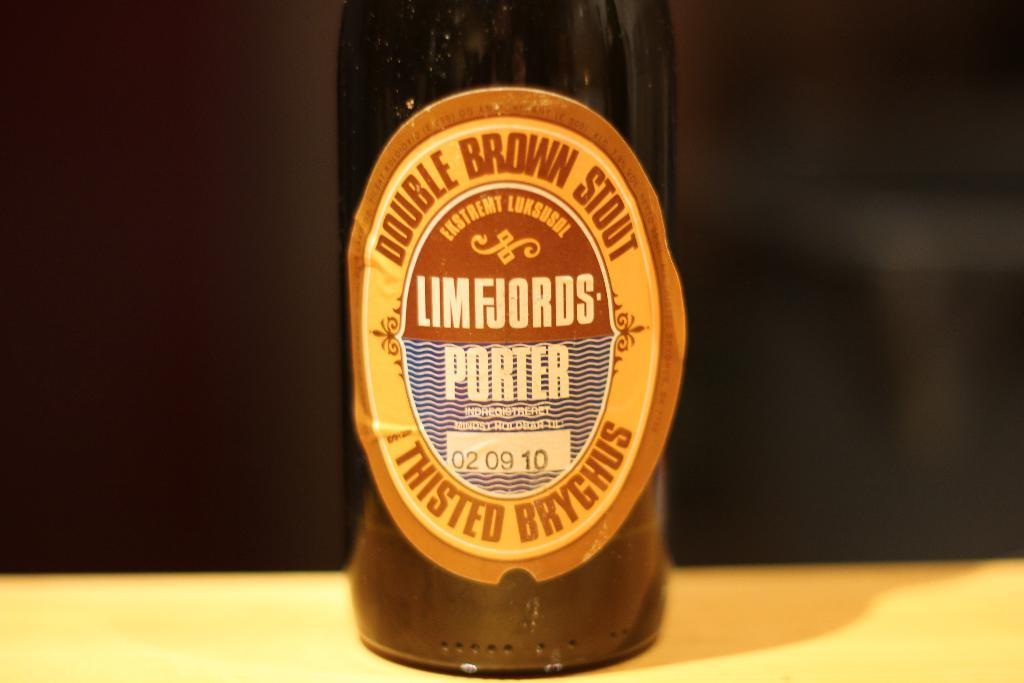<image>
Describe the image concisely. A bottle of Double Brown Stout Thisted Bryghus on a table. 